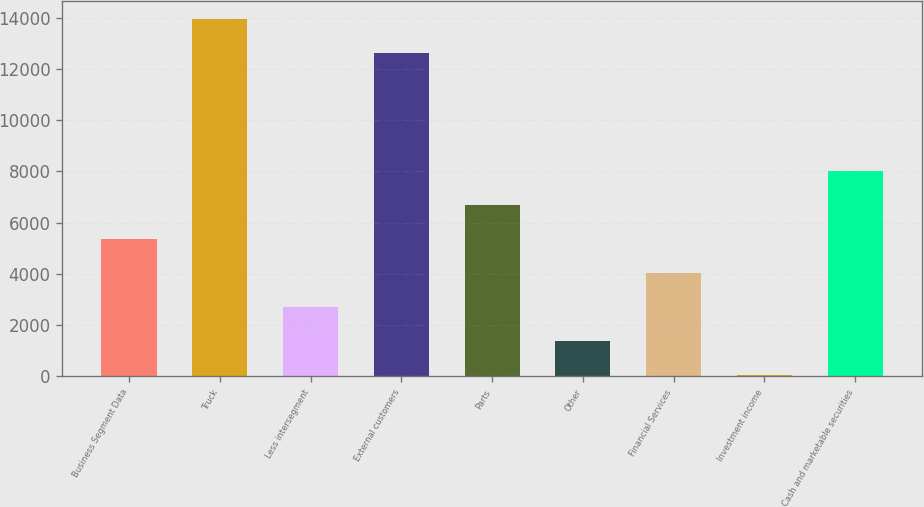Convert chart. <chart><loc_0><loc_0><loc_500><loc_500><bar_chart><fcel>Business Segment Data<fcel>Truck<fcel>Less intersegment<fcel>External customers<fcel>Parts<fcel>Other<fcel>Financial Services<fcel>Investment income<fcel>Cash and marketable securities<nl><fcel>5366.6<fcel>13962.8<fcel>2702.4<fcel>12630.7<fcel>6698.7<fcel>1370.3<fcel>4034.5<fcel>38.2<fcel>8030.8<nl></chart> 